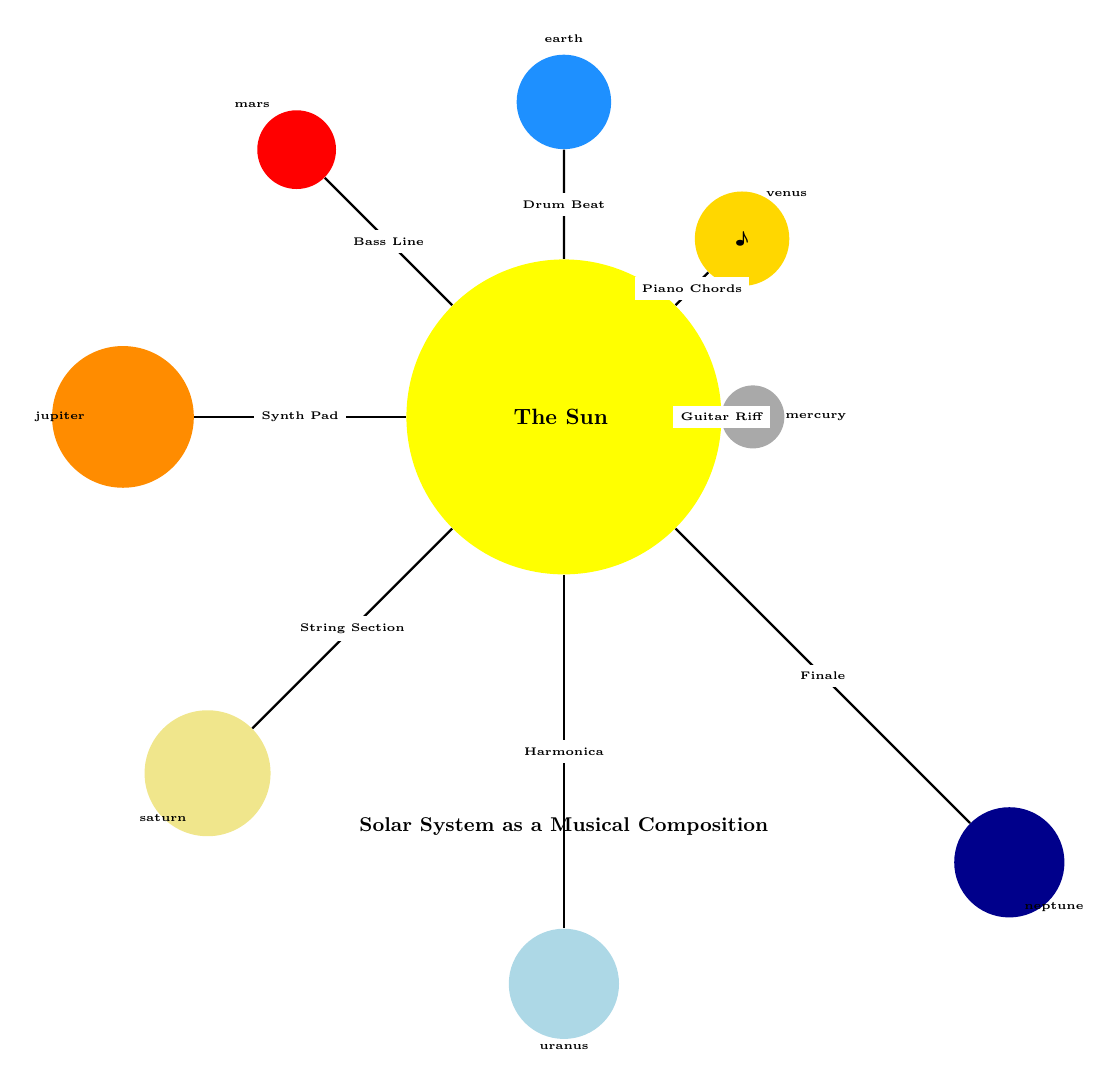What is the color of Mars? The diagram specifically colors Mars in a shade of red, which is represented as the "marscolor" in the code.
Answer: red Which planet is closest to the Sun? By examining the distances of each planet from the Sun, Mercury is located at the shortest distance (3 cm), making it the closest planet.
Answer: Mercury How many planets are depicted in the diagram? Counting the labeled nodes representing planets, there are a total of eight planets shown in the solar system diagram.
Answer: eight What musical instrument is associated with Jupiter? The diagram labels Jupiter with "Synth Pad" as the associated musical instrument, thus indicating that is the specific instrument related to that planet.
Answer: Synth Pad Which planet appears furthest from the Sun? Looking at the distances of the planets from the Sun in the diagram, Neptune is placed at the longest distance (10 cm), making it the furthest planet.
Answer: Neptune What symbol represents Venus? Venus is represented in the diagram by the music note "♪", specifically included as the symbol in the Venus node.
Answer: ♪ How many musical elements are depicted along the lines connecting the planets? The diagram features eight unique musical elements (instruments) labeled on the lines connecting the planets to the Sun, one for each planet.
Answer: eight Which planet has the same size as Earth in the diagram? Both Earth and Venus share the same size specification of 1.5 cm in the diagram, indicating they are depicted as equal in size.
Answer: Venus What is the main theme depicted in the solar system diagram? The title of the diagram states "Solar System as a Musical Composition," which frames the entire visual representation under this musical theme.
Answer: Solar System as a Musical Composition 